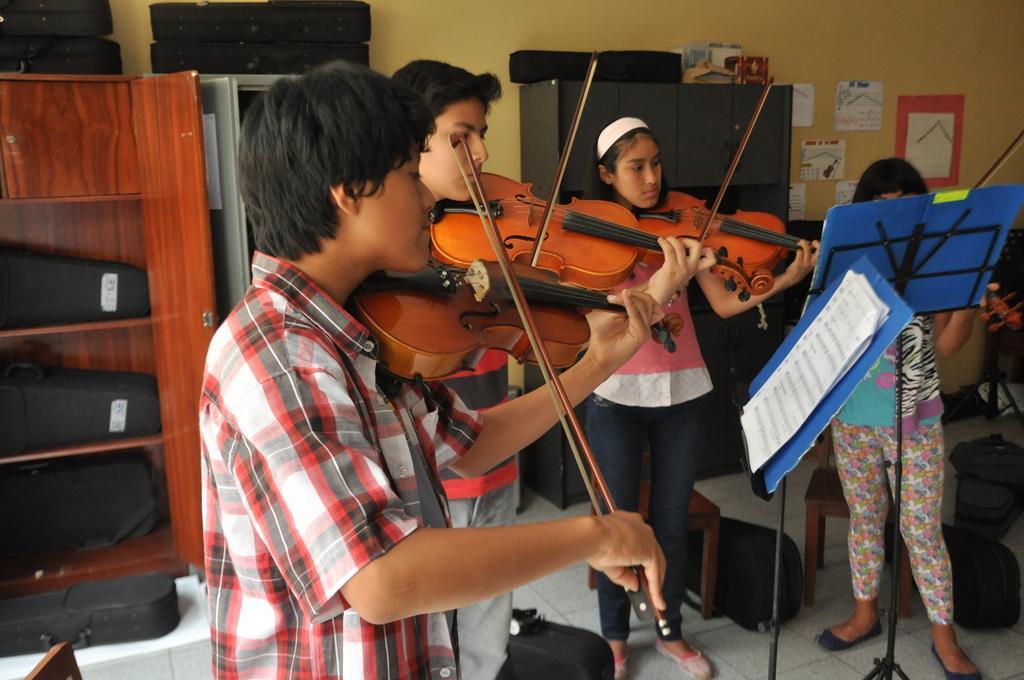Could you give a brief overview of what you see in this image? In the foreground of this image, there are two boys and two girls playing violin and there are two book stands in front of them. On the left, there is a cupboard with few violin bags and two violin bags are on the top of it and there is also a cupboard in the background on which two violin bags are on it. On the right side background, there is a cupboard on which a violin bag and there are posters on the wall. Few objects are on it and we can also see two chairs and few violin bags are on the floor behind the persons. 